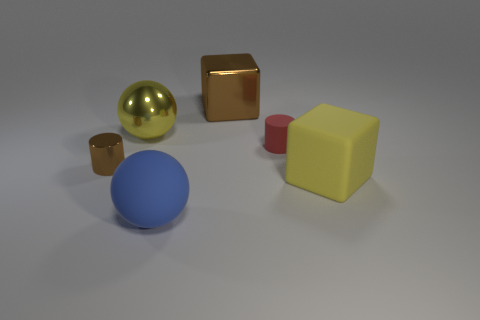Add 3 cyan balls. How many objects exist? 9 Add 5 tiny yellow matte cubes. How many tiny yellow matte cubes exist? 5 Subtract 0 cyan balls. How many objects are left? 6 Subtract all cylinders. How many objects are left? 4 Subtract all gray balls. Subtract all purple cubes. How many balls are left? 2 Subtract all large shiny objects. Subtract all tiny cylinders. How many objects are left? 2 Add 3 brown cylinders. How many brown cylinders are left? 4 